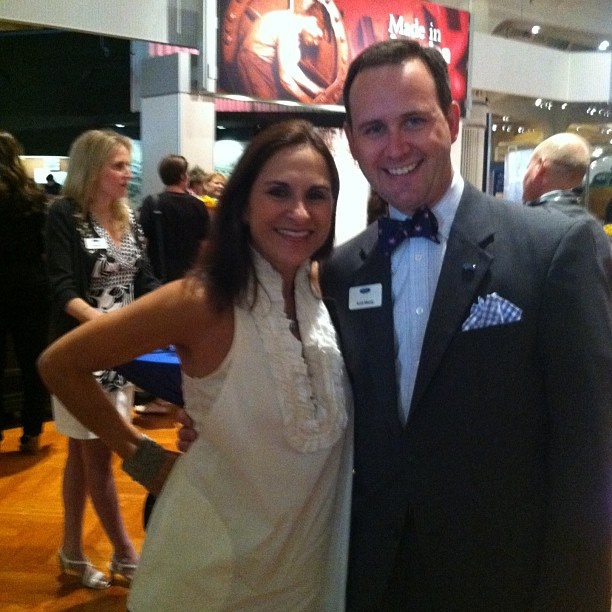Describe the objects in this image and their specific colors. I can see people in darkgray, black, gray, and brown tones, people in darkgray, gray, black, and maroon tones, people in darkgray, black, maroon, and gray tones, people in darkgray, black, maroon, olive, and gray tones, and people in darkgray, gray, ivory, and maroon tones in this image. 